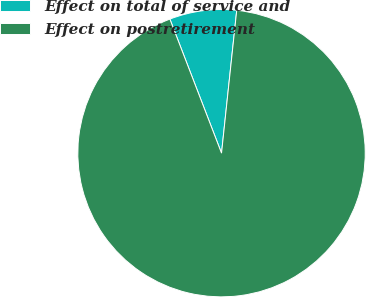Convert chart. <chart><loc_0><loc_0><loc_500><loc_500><pie_chart><fcel>Effect on total of service and<fcel>Effect on postretirement<nl><fcel>7.54%<fcel>92.46%<nl></chart> 